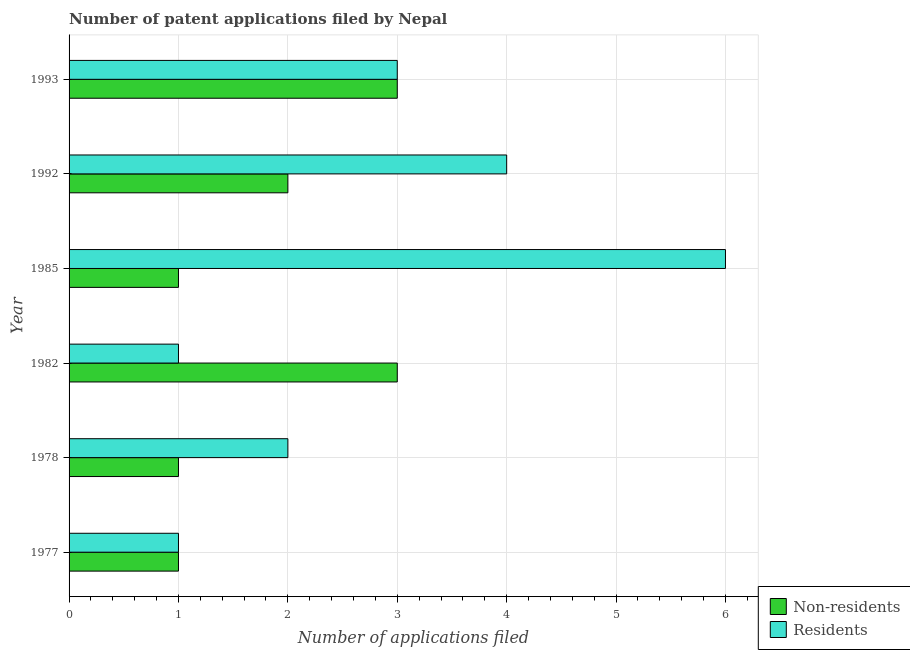Are the number of bars per tick equal to the number of legend labels?
Provide a succinct answer. Yes. Are the number of bars on each tick of the Y-axis equal?
Ensure brevity in your answer.  Yes. How many bars are there on the 5th tick from the top?
Give a very brief answer. 2. How many bars are there on the 4th tick from the bottom?
Your response must be concise. 2. What is the label of the 2nd group of bars from the top?
Keep it short and to the point. 1992. In how many cases, is the number of bars for a given year not equal to the number of legend labels?
Provide a succinct answer. 0. What is the number of patent applications by residents in 1978?
Keep it short and to the point. 2. Across all years, what is the minimum number of patent applications by non residents?
Make the answer very short. 1. In which year was the number of patent applications by residents minimum?
Your answer should be compact. 1977. What is the total number of patent applications by non residents in the graph?
Your answer should be compact. 11. What is the difference between the number of patent applications by non residents in 1977 and that in 1982?
Keep it short and to the point. -2. What is the average number of patent applications by residents per year?
Keep it short and to the point. 2.83. In the year 1982, what is the difference between the number of patent applications by non residents and number of patent applications by residents?
Give a very brief answer. 2. In how many years, is the number of patent applications by residents greater than 1.8 ?
Your answer should be very brief. 4. What is the ratio of the number of patent applications by residents in 1985 to that in 1993?
Your response must be concise. 2. Is the difference between the number of patent applications by non residents in 1982 and 1985 greater than the difference between the number of patent applications by residents in 1982 and 1985?
Your response must be concise. Yes. What is the difference between the highest and the second highest number of patent applications by residents?
Ensure brevity in your answer.  2. What is the difference between the highest and the lowest number of patent applications by non residents?
Ensure brevity in your answer.  2. Is the sum of the number of patent applications by non residents in 1978 and 1993 greater than the maximum number of patent applications by residents across all years?
Offer a very short reply. No. What does the 2nd bar from the top in 1992 represents?
Your answer should be compact. Non-residents. What does the 1st bar from the bottom in 1985 represents?
Give a very brief answer. Non-residents. Are all the bars in the graph horizontal?
Provide a short and direct response. Yes. What is the difference between two consecutive major ticks on the X-axis?
Provide a short and direct response. 1. Are the values on the major ticks of X-axis written in scientific E-notation?
Ensure brevity in your answer.  No. Does the graph contain grids?
Make the answer very short. Yes. How many legend labels are there?
Ensure brevity in your answer.  2. How are the legend labels stacked?
Your answer should be very brief. Vertical. What is the title of the graph?
Keep it short and to the point. Number of patent applications filed by Nepal. What is the label or title of the X-axis?
Provide a succinct answer. Number of applications filed. What is the label or title of the Y-axis?
Your answer should be compact. Year. What is the Number of applications filed of Residents in 1977?
Your response must be concise. 1. What is the Number of applications filed in Non-residents in 1978?
Give a very brief answer. 1. What is the Number of applications filed of Non-residents in 1982?
Provide a succinct answer. 3. What is the Number of applications filed in Residents in 1982?
Offer a very short reply. 1. What is the Number of applications filed of Non-residents in 1985?
Your response must be concise. 1. What is the Number of applications filed in Non-residents in 1992?
Offer a terse response. 2. What is the Number of applications filed of Residents in 1992?
Give a very brief answer. 4. What is the Number of applications filed of Residents in 1993?
Ensure brevity in your answer.  3. Across all years, what is the maximum Number of applications filed in Non-residents?
Your response must be concise. 3. Across all years, what is the maximum Number of applications filed in Residents?
Provide a short and direct response. 6. Across all years, what is the minimum Number of applications filed in Residents?
Your answer should be very brief. 1. What is the difference between the Number of applications filed of Non-residents in 1977 and that in 1978?
Give a very brief answer. 0. What is the difference between the Number of applications filed in Residents in 1977 and that in 1978?
Make the answer very short. -1. What is the difference between the Number of applications filed in Residents in 1977 and that in 1982?
Keep it short and to the point. 0. What is the difference between the Number of applications filed of Residents in 1978 and that in 1982?
Ensure brevity in your answer.  1. What is the difference between the Number of applications filed in Non-residents in 1978 and that in 1985?
Provide a short and direct response. 0. What is the difference between the Number of applications filed in Residents in 1978 and that in 1985?
Provide a succinct answer. -4. What is the difference between the Number of applications filed in Residents in 1978 and that in 1992?
Your answer should be very brief. -2. What is the difference between the Number of applications filed of Residents in 1978 and that in 1993?
Your answer should be compact. -1. What is the difference between the Number of applications filed in Residents in 1982 and that in 1992?
Offer a very short reply. -3. What is the difference between the Number of applications filed in Non-residents in 1982 and that in 1993?
Provide a short and direct response. 0. What is the difference between the Number of applications filed of Residents in 1982 and that in 1993?
Provide a succinct answer. -2. What is the difference between the Number of applications filed in Non-residents in 1985 and that in 1992?
Keep it short and to the point. -1. What is the difference between the Number of applications filed of Non-residents in 1985 and that in 1993?
Make the answer very short. -2. What is the difference between the Number of applications filed of Residents in 1985 and that in 1993?
Your answer should be very brief. 3. What is the difference between the Number of applications filed in Non-residents in 1977 and the Number of applications filed in Residents in 1985?
Provide a short and direct response. -5. What is the difference between the Number of applications filed of Non-residents in 1977 and the Number of applications filed of Residents in 1992?
Your answer should be very brief. -3. What is the difference between the Number of applications filed of Non-residents in 1978 and the Number of applications filed of Residents in 1985?
Make the answer very short. -5. What is the difference between the Number of applications filed of Non-residents in 1978 and the Number of applications filed of Residents in 1992?
Provide a short and direct response. -3. What is the difference between the Number of applications filed of Non-residents in 1978 and the Number of applications filed of Residents in 1993?
Your answer should be compact. -2. What is the difference between the Number of applications filed of Non-residents in 1982 and the Number of applications filed of Residents in 1985?
Your answer should be very brief. -3. What is the difference between the Number of applications filed of Non-residents in 1985 and the Number of applications filed of Residents in 1992?
Ensure brevity in your answer.  -3. What is the difference between the Number of applications filed of Non-residents in 1992 and the Number of applications filed of Residents in 1993?
Provide a short and direct response. -1. What is the average Number of applications filed of Non-residents per year?
Your answer should be compact. 1.83. What is the average Number of applications filed of Residents per year?
Your answer should be very brief. 2.83. In the year 1978, what is the difference between the Number of applications filed of Non-residents and Number of applications filed of Residents?
Your answer should be very brief. -1. In the year 1982, what is the difference between the Number of applications filed in Non-residents and Number of applications filed in Residents?
Ensure brevity in your answer.  2. In the year 1985, what is the difference between the Number of applications filed in Non-residents and Number of applications filed in Residents?
Give a very brief answer. -5. In the year 1992, what is the difference between the Number of applications filed of Non-residents and Number of applications filed of Residents?
Provide a short and direct response. -2. What is the ratio of the Number of applications filed of Non-residents in 1977 to that in 1982?
Make the answer very short. 0.33. What is the ratio of the Number of applications filed of Residents in 1977 to that in 1982?
Your response must be concise. 1. What is the ratio of the Number of applications filed in Non-residents in 1978 to that in 1982?
Make the answer very short. 0.33. What is the ratio of the Number of applications filed of Non-residents in 1978 to that in 1992?
Your answer should be compact. 0.5. What is the ratio of the Number of applications filed in Non-residents in 1982 to that in 1985?
Offer a terse response. 3. What is the ratio of the Number of applications filed in Non-residents in 1982 to that in 1993?
Your answer should be compact. 1. What is the ratio of the Number of applications filed of Residents in 1982 to that in 1993?
Keep it short and to the point. 0.33. What is the ratio of the Number of applications filed of Non-residents in 1985 to that in 1993?
Ensure brevity in your answer.  0.33. What is the ratio of the Number of applications filed in Non-residents in 1992 to that in 1993?
Provide a short and direct response. 0.67. What is the difference between the highest and the second highest Number of applications filed of Non-residents?
Keep it short and to the point. 0. What is the difference between the highest and the lowest Number of applications filed of Non-residents?
Provide a succinct answer. 2. 